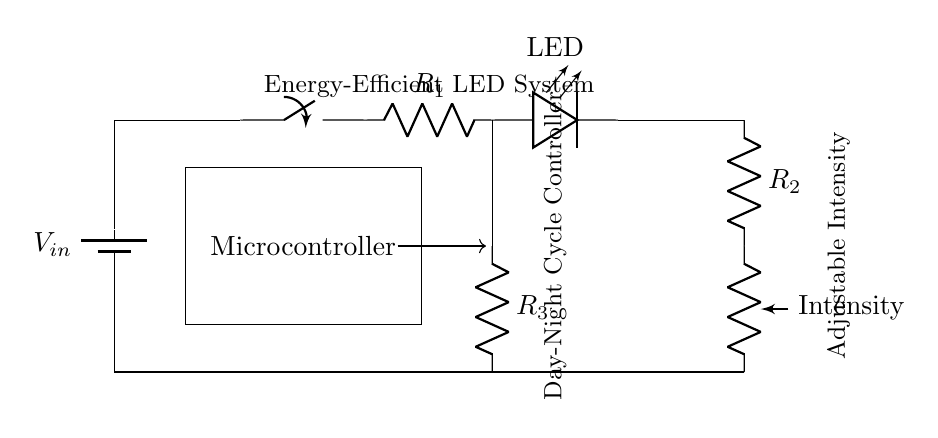What is the input voltage for this circuit? The input voltage is given as V_in, which indicates that it is an unspecified voltage supplied to the circuit, typically a battery voltage.
Answer: V_in What component controls the intensity of the LED? The component that controls the intensity of the LED is the potentiometer, as indicated in the circuit diagram. It allows for adjustable resistance, thus varying the current flowing through the LED.
Answer: Potentiometer How many resistors are present in this circuit? The circuit diagram shows three resistors: R1, R2, and R3, which are labeled at different points in the circuit layout.
Answer: Three What component is used to simulate the day-night cycle? The day-night cycle simulation is managed by the microcontroller, which is represented as a block in the circuit and is responsible for controlling the LED's operational pattern.
Answer: Microcontroller What is the role of the switch in this circuit? The switch is used to control the on/off state of the entire circuit, connecting or disconnecting the power supply to the components. When closed, it allows current to flow; when open, it interrupts the circuit.
Answer: On/Off control What does R2 specifically lead to in the circuit? R2 connects the LED to the potentiometer, indicating that it is positioned in series with the LED, allowing for control over its brightness based on the resistance set by the potentiometer.
Answer: LED Which component indicates the efficiency of this lighting system? The energy-efficient aspect is indicated by the use of the LED, which is inherently designed for low energy consumption compared to traditional lighting methods like incandescent bulbs.
Answer: LED 